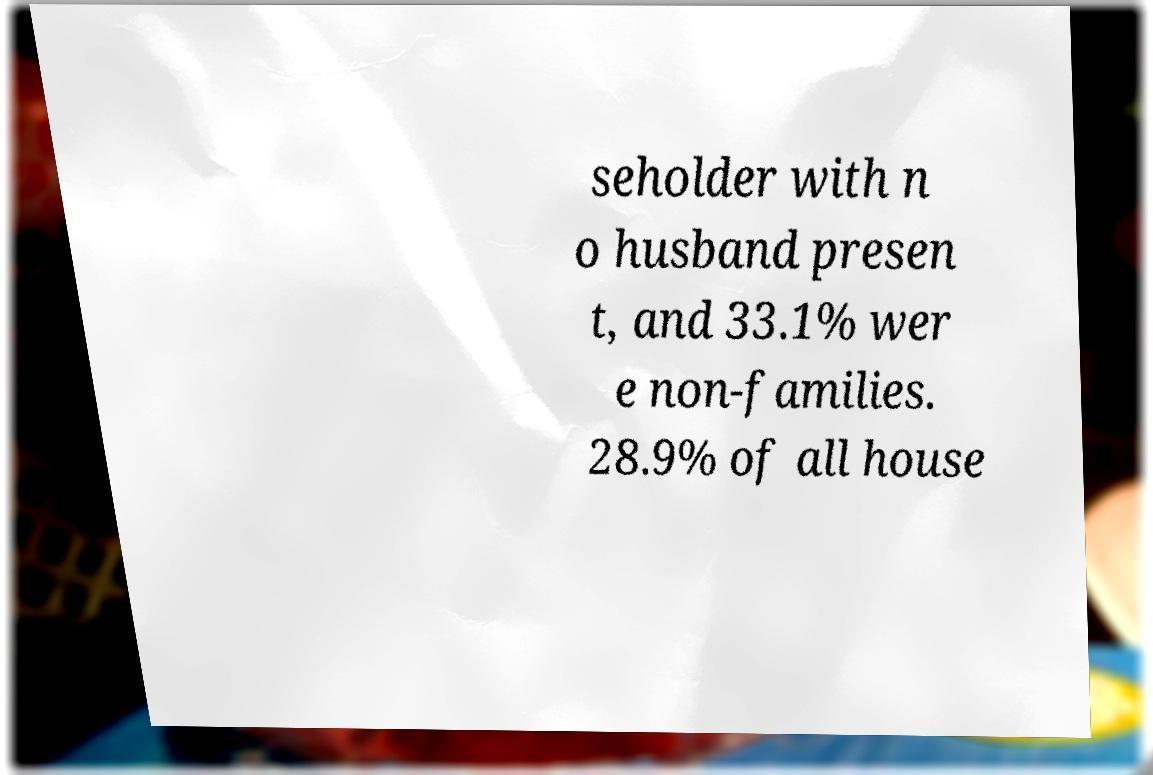Could you extract and type out the text from this image? seholder with n o husband presen t, and 33.1% wer e non-families. 28.9% of all house 